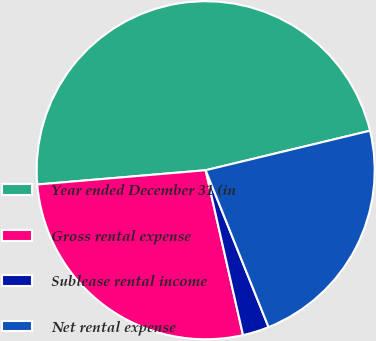Convert chart to OTSL. <chart><loc_0><loc_0><loc_500><loc_500><pie_chart><fcel>Year ended December 31 (in<fcel>Gross rental expense<fcel>Sublease rental income<fcel>Net rental expense<nl><fcel>47.59%<fcel>27.2%<fcel>2.52%<fcel>22.69%<nl></chart> 